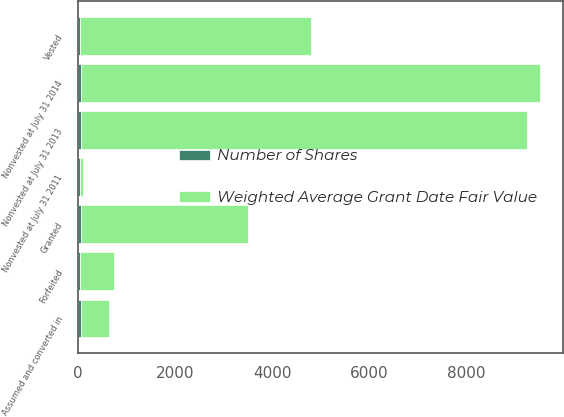Convert chart. <chart><loc_0><loc_0><loc_500><loc_500><stacked_bar_chart><ecel><fcel>Nonvested at July 31 2011<fcel>Granted<fcel>Assumed and converted in<fcel>Vested<fcel>Forfeited<fcel>Nonvested at July 31 2013<fcel>Nonvested at July 31 2014<nl><fcel>Weighted Average Grant Date Fair Value<fcel>62.46<fcel>3436<fcel>575<fcel>4763<fcel>696<fcel>9184<fcel>9455<nl><fcel>Number of Shares<fcel>37.92<fcel>55.02<fcel>54.51<fcel>34.13<fcel>39.56<fcel>55.23<fcel>62.46<nl></chart> 